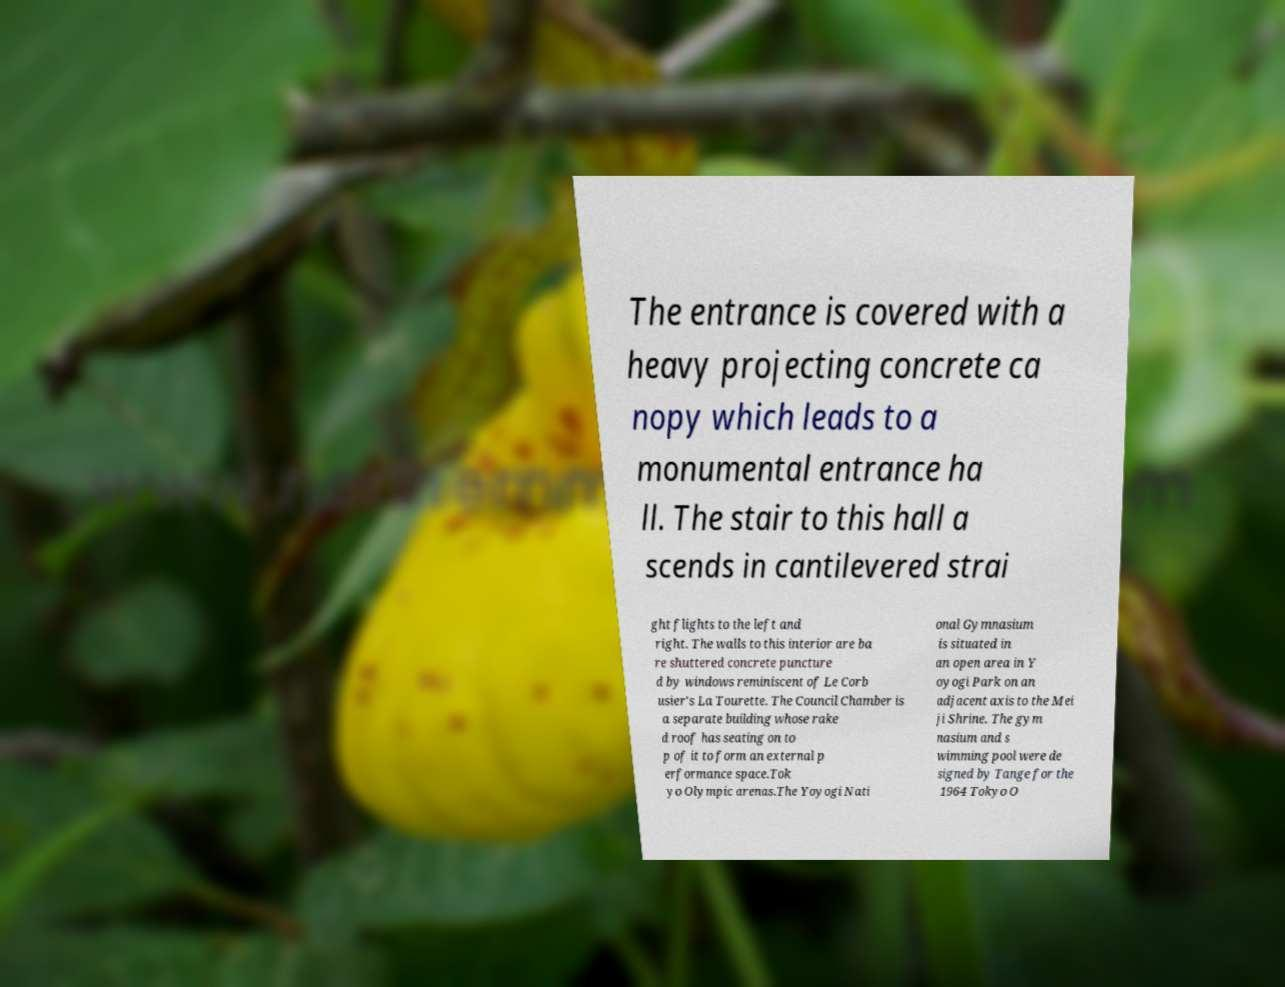Could you assist in decoding the text presented in this image and type it out clearly? The entrance is covered with a heavy projecting concrete ca nopy which leads to a monumental entrance ha ll. The stair to this hall a scends in cantilevered strai ght flights to the left and right. The walls to this interior are ba re shuttered concrete puncture d by windows reminiscent of Le Corb usier's La Tourette. The Council Chamber is a separate building whose rake d roof has seating on to p of it to form an external p erformance space.Tok yo Olympic arenas.The Yoyogi Nati onal Gymnasium is situated in an open area in Y oyogi Park on an adjacent axis to the Mei ji Shrine. The gym nasium and s wimming pool were de signed by Tange for the 1964 Tokyo O 